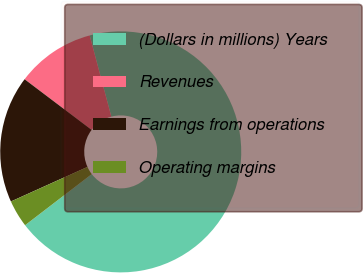Convert chart to OTSL. <chart><loc_0><loc_0><loc_500><loc_500><pie_chart><fcel>(Dollars in millions) Years<fcel>Revenues<fcel>Earnings from operations<fcel>Operating margins<nl><fcel>68.73%<fcel>10.55%<fcel>17.05%<fcel>3.66%<nl></chart> 